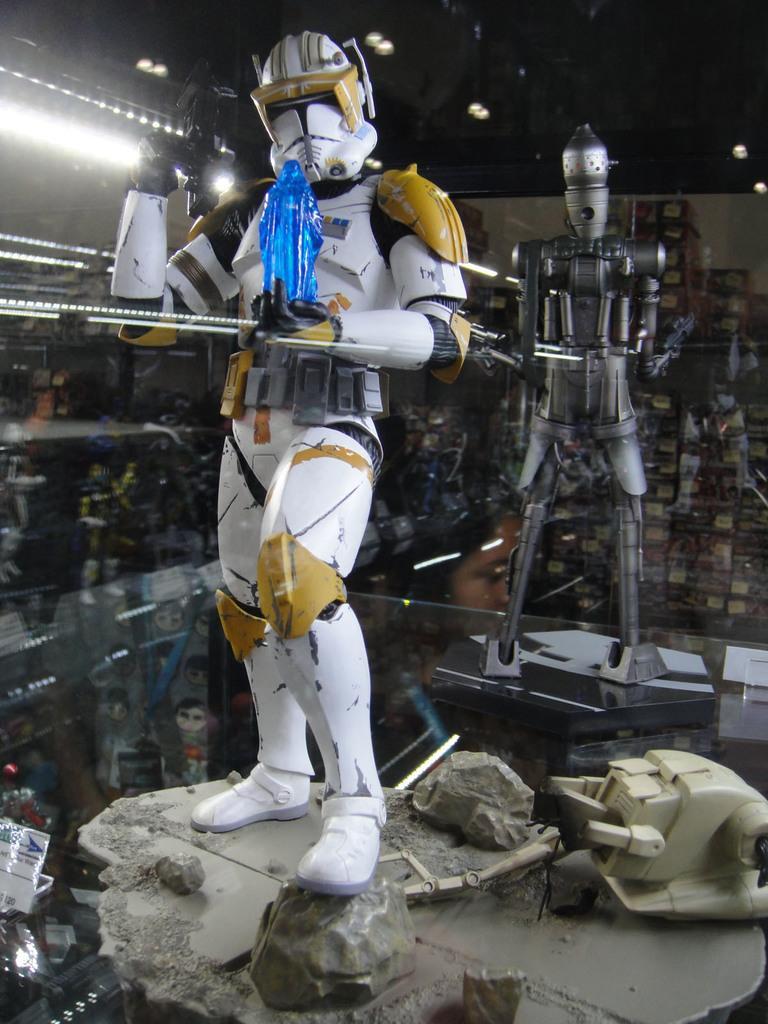Can you describe this image briefly? In this picture, we see a robot holding a blue color water bottle. Behind that, we see another robot. In the background, we see boxes in white and yellow color. At the top of the picture, we see the lights. On the left side, we see many robots. At the bottom of the picture, we see a stone and a machinery equipment. 